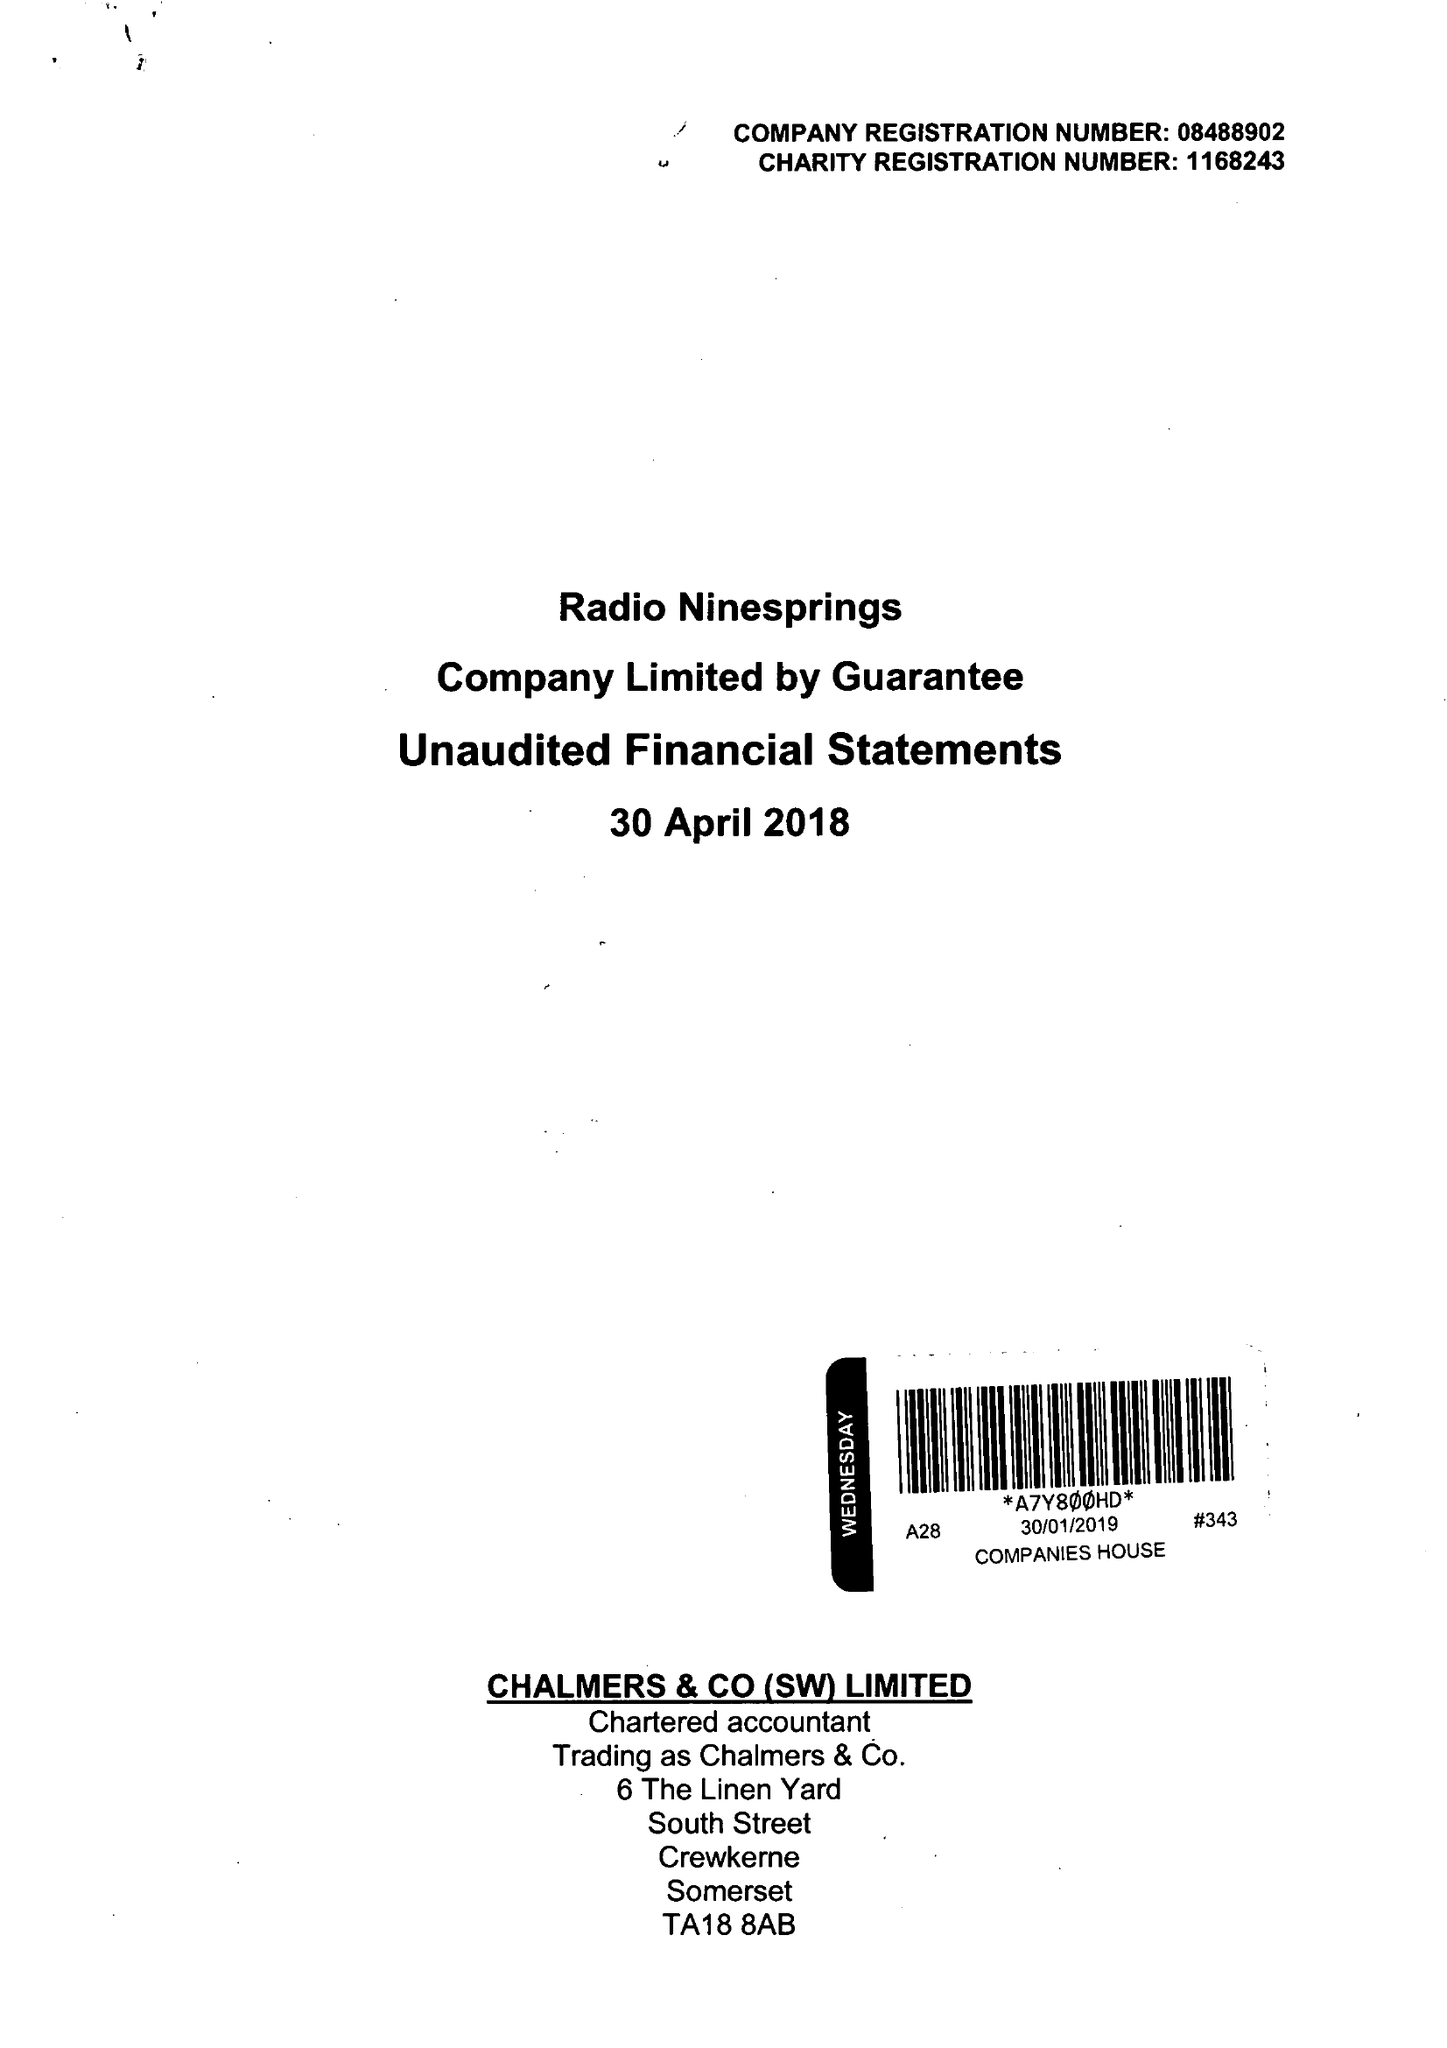What is the value for the address__street_line?
Answer the question using a single word or phrase. WATERLOO LANE 